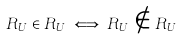Convert formula to latex. <formula><loc_0><loc_0><loc_500><loc_500>R _ { U } \in R _ { U } \iff R _ { U } \notin R _ { U }</formula> 